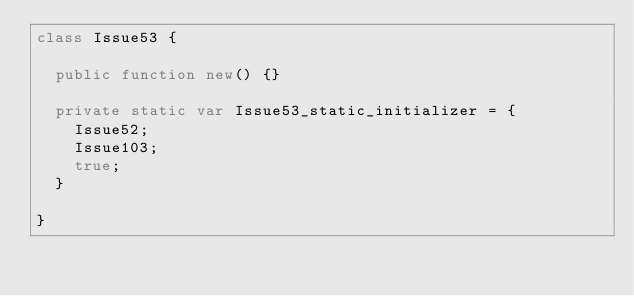<code> <loc_0><loc_0><loc_500><loc_500><_Haxe_>class Issue53 {

	public function new() {}

	private static var Issue53_static_initializer = {
		Issue52;
		Issue103;
		true;
	}

}</code> 